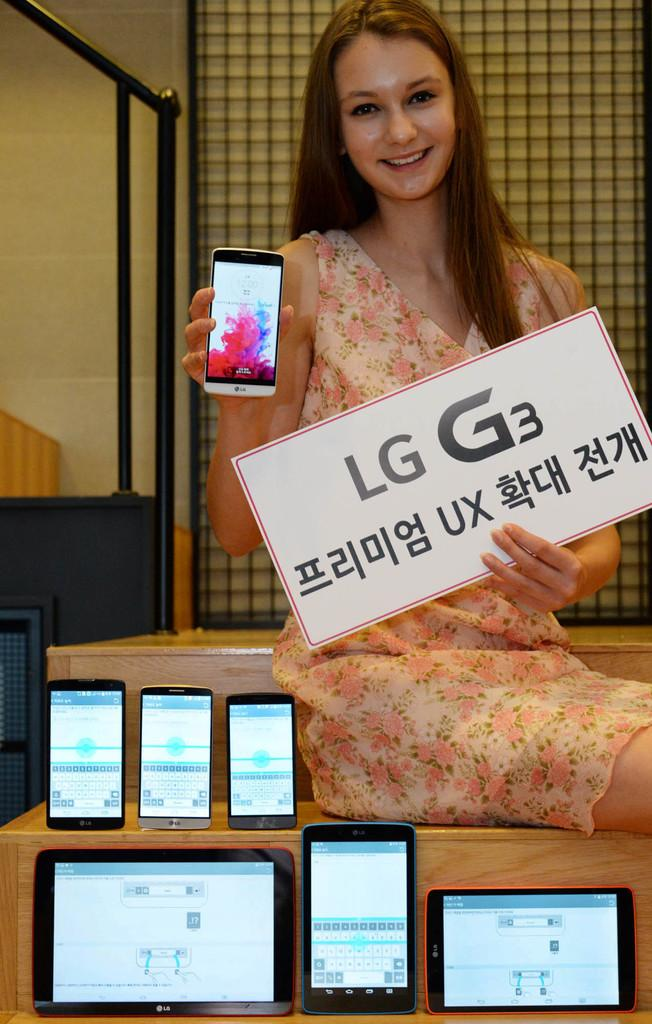What is the person in the image doing? The person is sitting on a table. What is the person holding in the image? The person is holding a mobile and a name board. What type of furniture is present in the image? There is a table in the image. What electronic devices can be seen in the image? There is a mobile phone and iPads in the image. What type of church can be seen in the background of the image? There is no church present in the image. Is there an industry depicted in the image? There is no industry depicted in the image. 